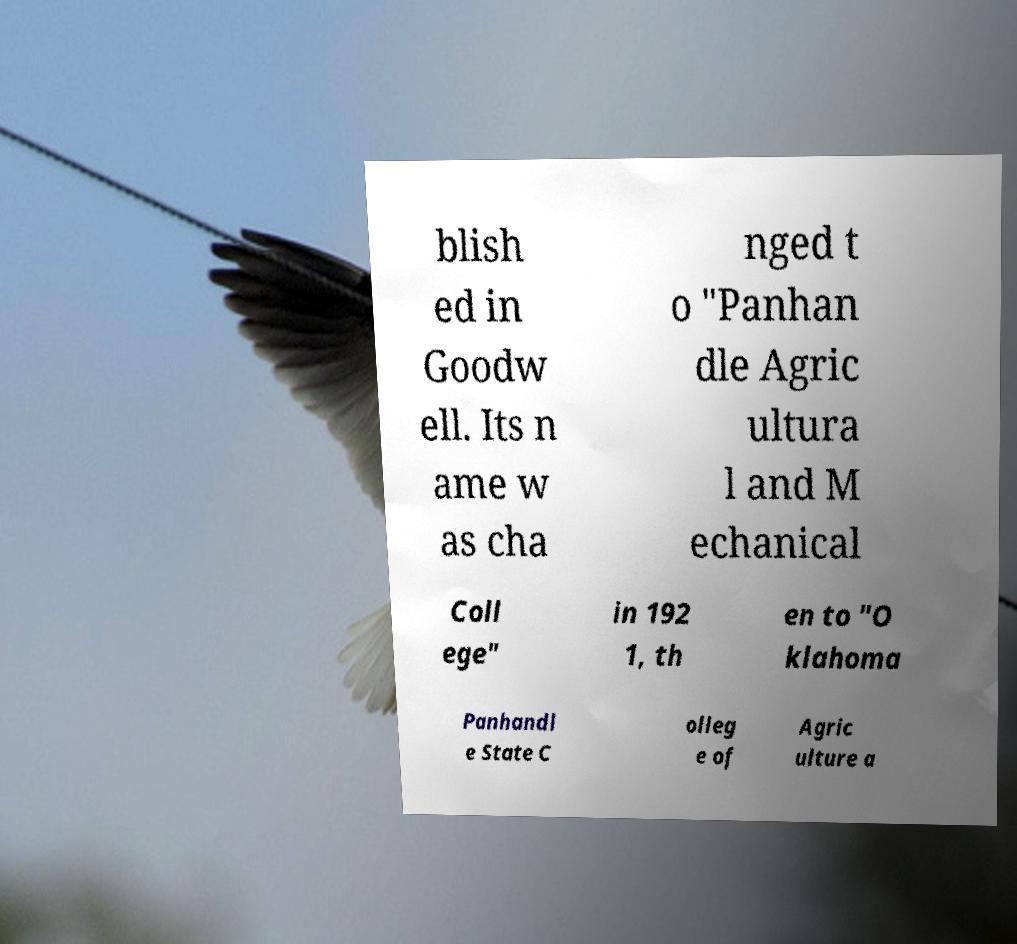Can you read and provide the text displayed in the image?This photo seems to have some interesting text. Can you extract and type it out for me? blish ed in Goodw ell. Its n ame w as cha nged t o "Panhan dle Agric ultura l and M echanical Coll ege" in 192 1, th en to "O klahoma Panhandl e State C olleg e of Agric ulture a 